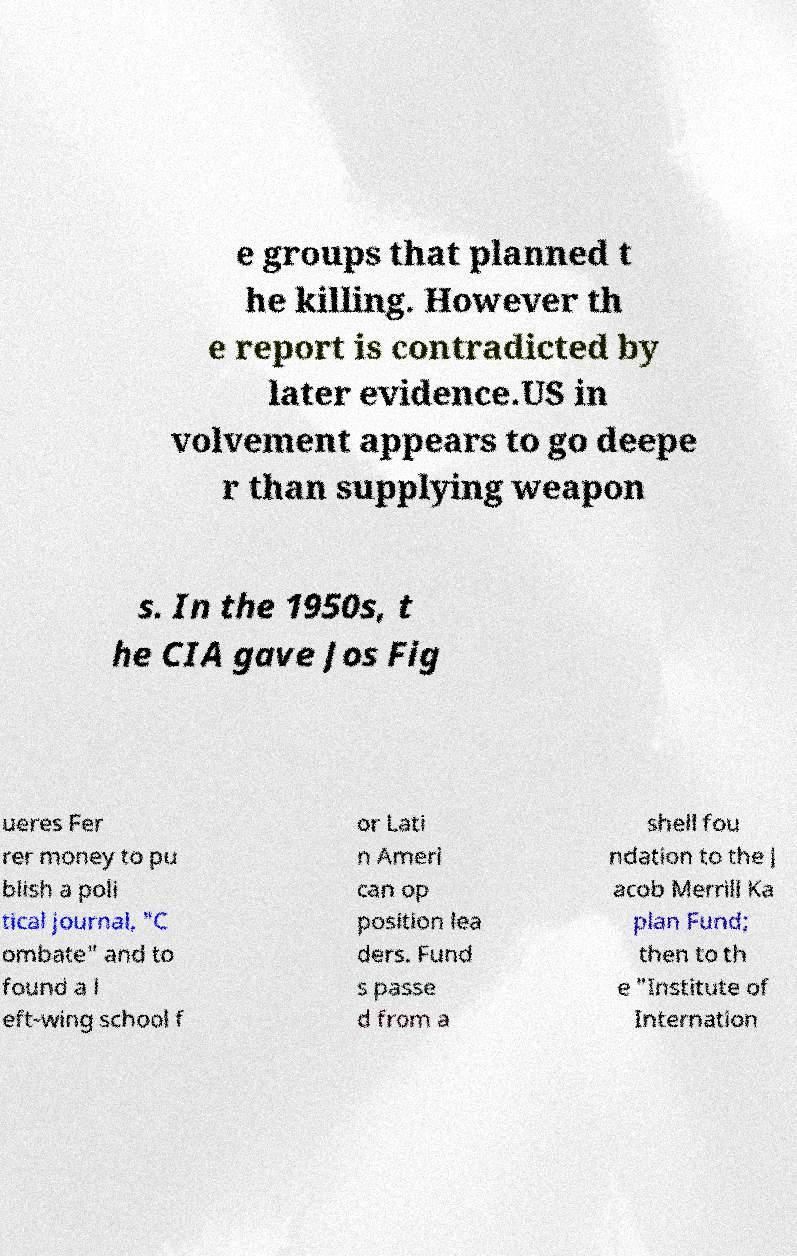Can you read and provide the text displayed in the image?This photo seems to have some interesting text. Can you extract and type it out for me? e groups that planned t he killing. However th e report is contradicted by later evidence.US in volvement appears to go deepe r than supplying weapon s. In the 1950s, t he CIA gave Jos Fig ueres Fer rer money to pu blish a poli tical journal, "C ombate" and to found a l eft-wing school f or Lati n Ameri can op position lea ders. Fund s passe d from a shell fou ndation to the J acob Merrill Ka plan Fund; then to th e "Institute of Internation 